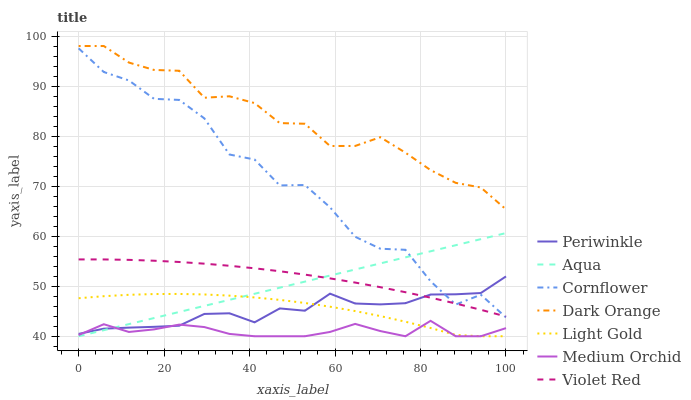Does Medium Orchid have the minimum area under the curve?
Answer yes or no. Yes. Does Dark Orange have the maximum area under the curve?
Answer yes or no. Yes. Does Violet Red have the minimum area under the curve?
Answer yes or no. No. Does Violet Red have the maximum area under the curve?
Answer yes or no. No. Is Aqua the smoothest?
Answer yes or no. Yes. Is Cornflower the roughest?
Answer yes or no. Yes. Is Violet Red the smoothest?
Answer yes or no. No. Is Violet Red the roughest?
Answer yes or no. No. Does Medium Orchid have the lowest value?
Answer yes or no. Yes. Does Violet Red have the lowest value?
Answer yes or no. No. Does Dark Orange have the highest value?
Answer yes or no. Yes. Does Violet Red have the highest value?
Answer yes or no. No. Is Light Gold less than Dark Orange?
Answer yes or no. Yes. Is Dark Orange greater than Light Gold?
Answer yes or no. Yes. Does Light Gold intersect Aqua?
Answer yes or no. Yes. Is Light Gold less than Aqua?
Answer yes or no. No. Is Light Gold greater than Aqua?
Answer yes or no. No. Does Light Gold intersect Dark Orange?
Answer yes or no. No. 